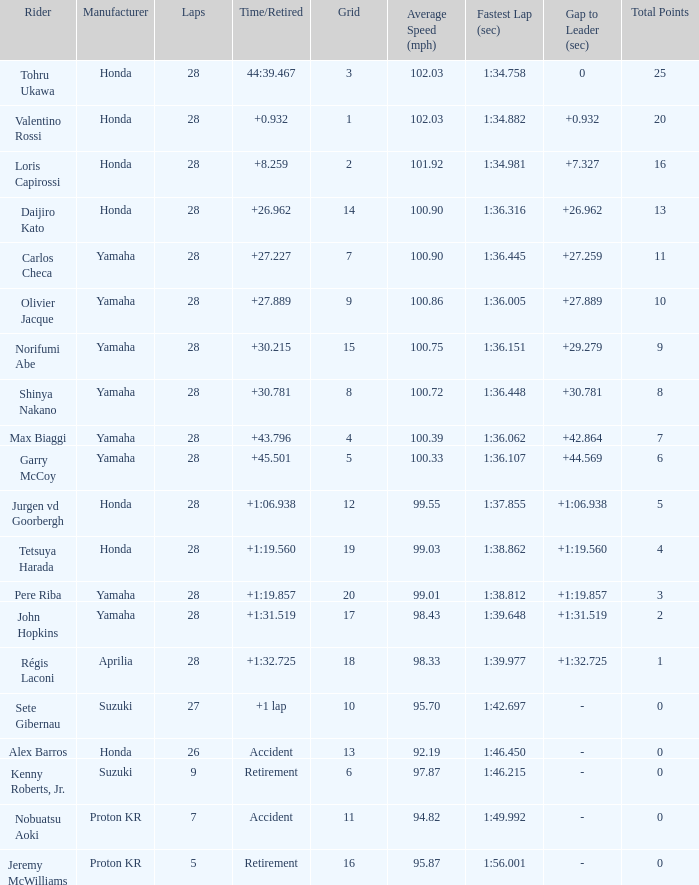How many laps did pere riba ride? 28.0. Could you help me parse every detail presented in this table? {'header': ['Rider', 'Manufacturer', 'Laps', 'Time/Retired', 'Grid', 'Average Speed (mph)', 'Fastest Lap (sec)', 'Gap to Leader (sec)', 'Total Points'], 'rows': [['Tohru Ukawa', 'Honda', '28', '44:39.467', '3', '102.03', '1:34.758', '0', '25'], ['Valentino Rossi', 'Honda', '28', '+0.932', '1', '102.03', '1:34.882', '+0.932', '20'], ['Loris Capirossi', 'Honda', '28', '+8.259', '2', '101.92', '1:34.981', '+7.327', '16'], ['Daijiro Kato', 'Honda', '28', '+26.962', '14', '100.90', '1:36.316', '+26.962', '13'], ['Carlos Checa', 'Yamaha', '28', '+27.227', '7', '100.90', '1:36.445', '+27.259', '11'], ['Olivier Jacque', 'Yamaha', '28', '+27.889', '9', '100.86', '1:36.005', '+27.889', '10'], ['Norifumi Abe', 'Yamaha', '28', '+30.215', '15', '100.75', '1:36.151', '+29.279', '9'], ['Shinya Nakano', 'Yamaha', '28', '+30.781', '8', '100.72', '1:36.448', '+30.781', '8'], ['Max Biaggi', 'Yamaha', '28', '+43.796', '4', '100.39', '1:36.062', '+42.864', '7'], ['Garry McCoy', 'Yamaha', '28', '+45.501', '5', '100.33', '1:36.107', '+44.569', '6'], ['Jurgen vd Goorbergh', 'Honda', '28', '+1:06.938', '12', '99.55', '1:37.855', '+1:06.938', '5'], ['Tetsuya Harada', 'Honda', '28', '+1:19.560', '19', '99.03', '1:38.862', '+1:19.560', '4'], ['Pere Riba', 'Yamaha', '28', '+1:19.857', '20', '99.01', '1:38.812', '+1:19.857', '3'], ['John Hopkins', 'Yamaha', '28', '+1:31.519', '17', '98.43', '1:39.648', '+1:31.519', '2'], ['Régis Laconi', 'Aprilia', '28', '+1:32.725', '18', '98.33', '1:39.977', '+1:32.725', '1'], ['Sete Gibernau', 'Suzuki', '27', '+1 lap', '10', '95.70', '1:42.697', '-', '0'], ['Alex Barros', 'Honda', '26', 'Accident', '13', '92.19', '1:46.450', '-', '0'], ['Kenny Roberts, Jr.', 'Suzuki', '9', 'Retirement', '6', '97.87', '1:46.215', '-', '0'], ['Nobuatsu Aoki', 'Proton KR', '7', 'Accident', '11', '94.82', '1:49.992', '-', '0'], ['Jeremy McWilliams', 'Proton KR', '5', 'Retirement', '16', '95.87', '1:56.001', '-', '0']]} 